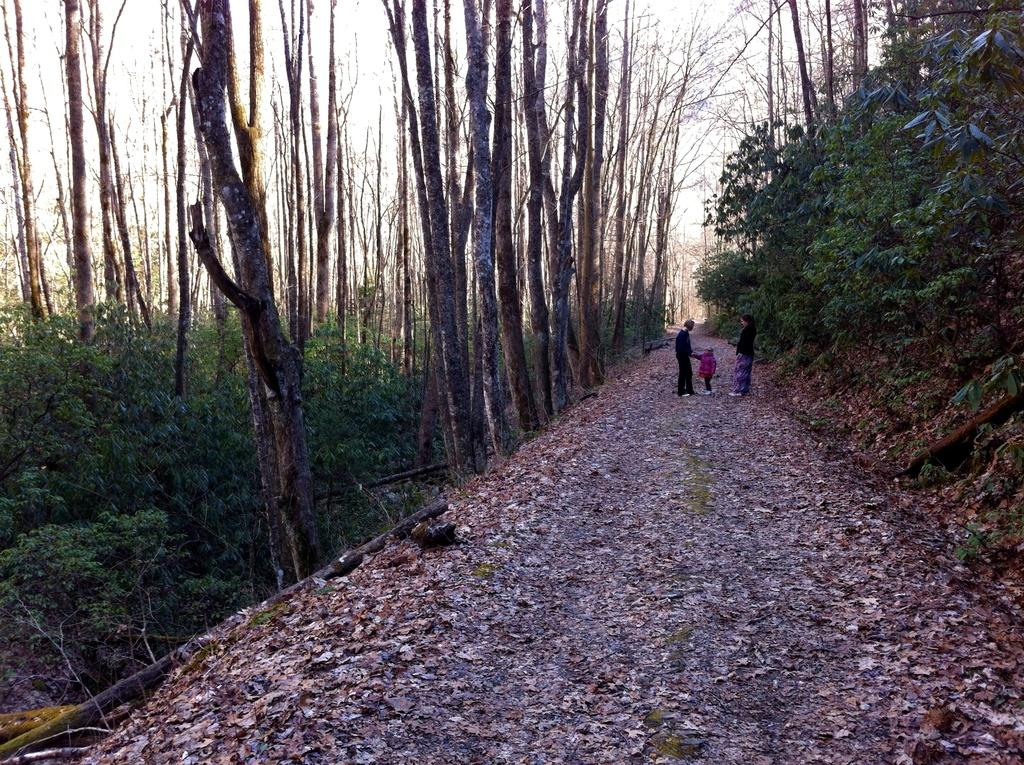What is the main feature of the image? There is a road in the image. How many people can be seen on the road? There are three people on the road. What type of vegetation is present alongside the road? There are trees on the sides of the road. What else can be seen on the road? Dried leaves are present on the road. What is visible in the background of the image? There is sky visible in the background of the image. Where is the bone located in the image? There is no bone present in the image. Can you see any cobwebs on the trees in the image? There is no mention of cobwebs in the image, and they are not visible in the provided facts. 